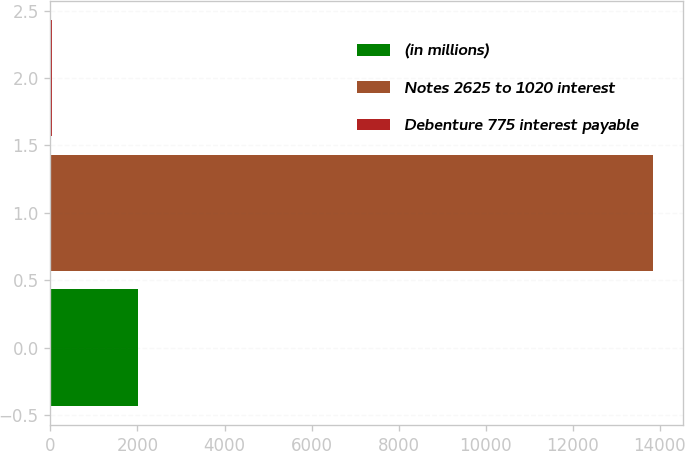Convert chart. <chart><loc_0><loc_0><loc_500><loc_500><bar_chart><fcel>(in millions)<fcel>Notes 2625 to 1020 interest<fcel>Debenture 775 interest payable<nl><fcel>2016<fcel>13839<fcel>42<nl></chart> 